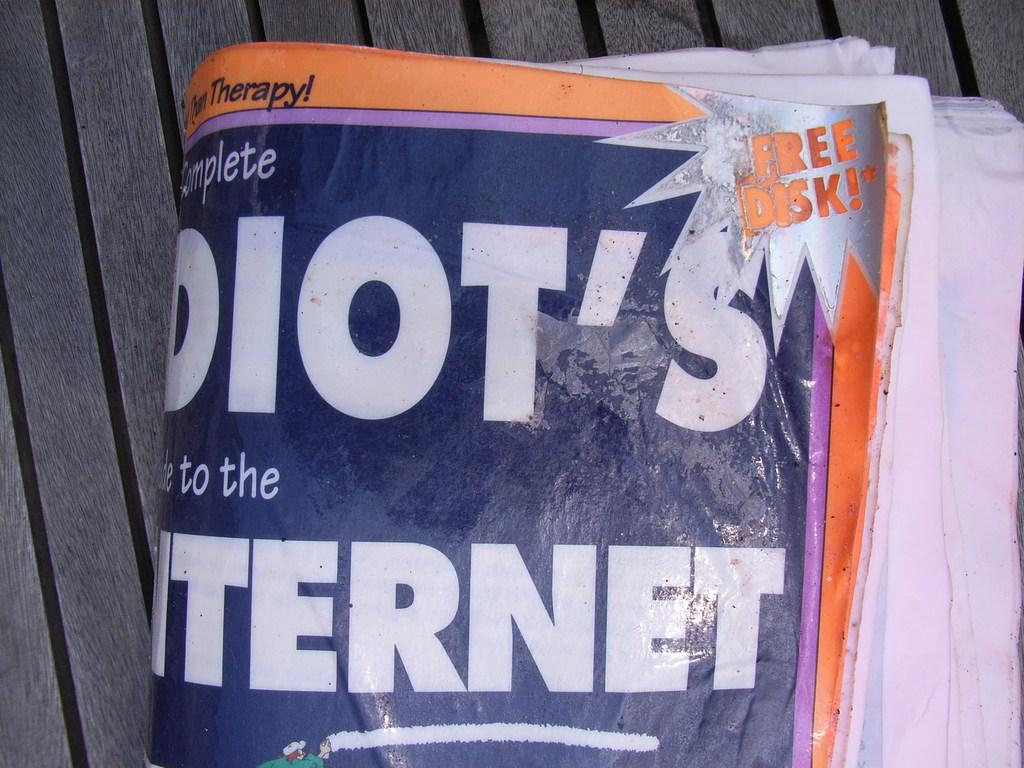What can be seen hanging on the wooden surface in the image? There are posters in the image. Can you describe the material of the surface where the posters are placed? The posters are on a wooden surface. How many waves can be seen crashing against the harbor in the image? There is no harbor or waves present in the image; it only features posters on a wooden surface. 